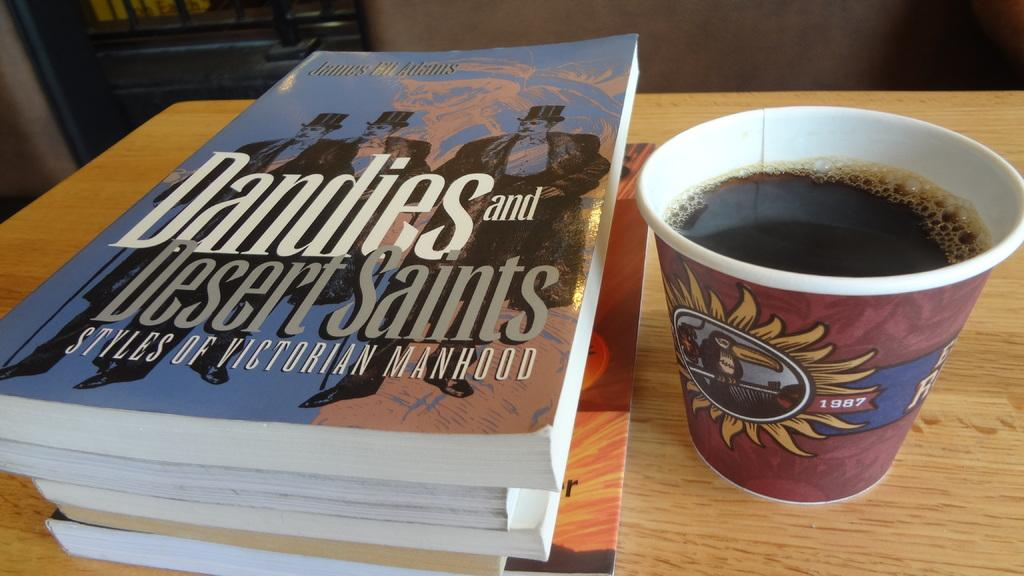What type of table is in the image? There is a wooden table in the image. What is on the table? There is a glass with a cool drink and books placed on the table. What type of lace is used to decorate the books in the image? There is no lace present on the books in the image. 